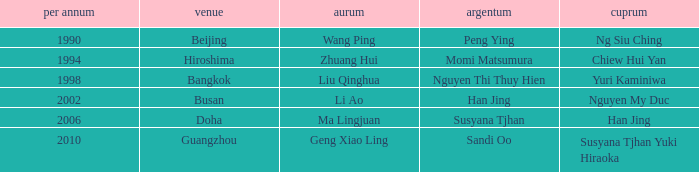What Silver has a Golf of Li AO? Han Jing. 